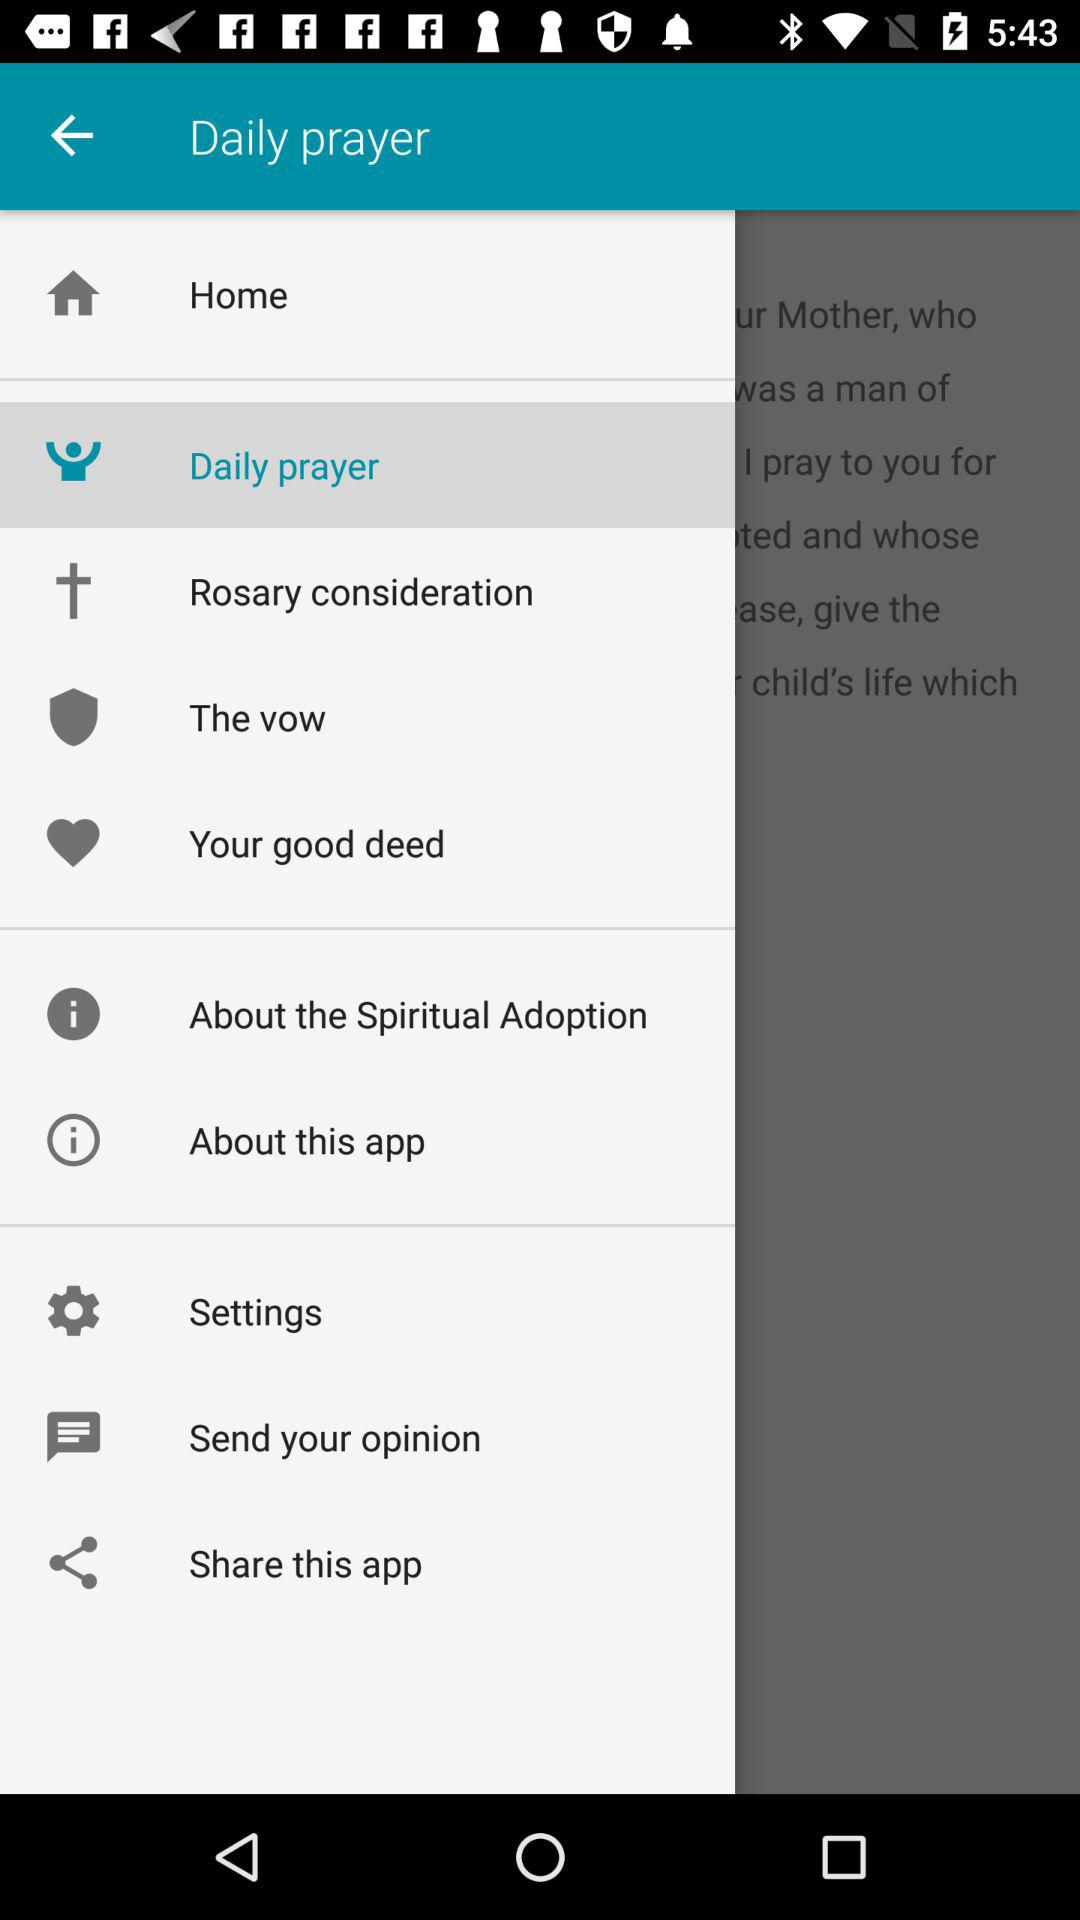Which item is currently selected in the menu? The item "Daily prayer" is currently selected in the menu. 